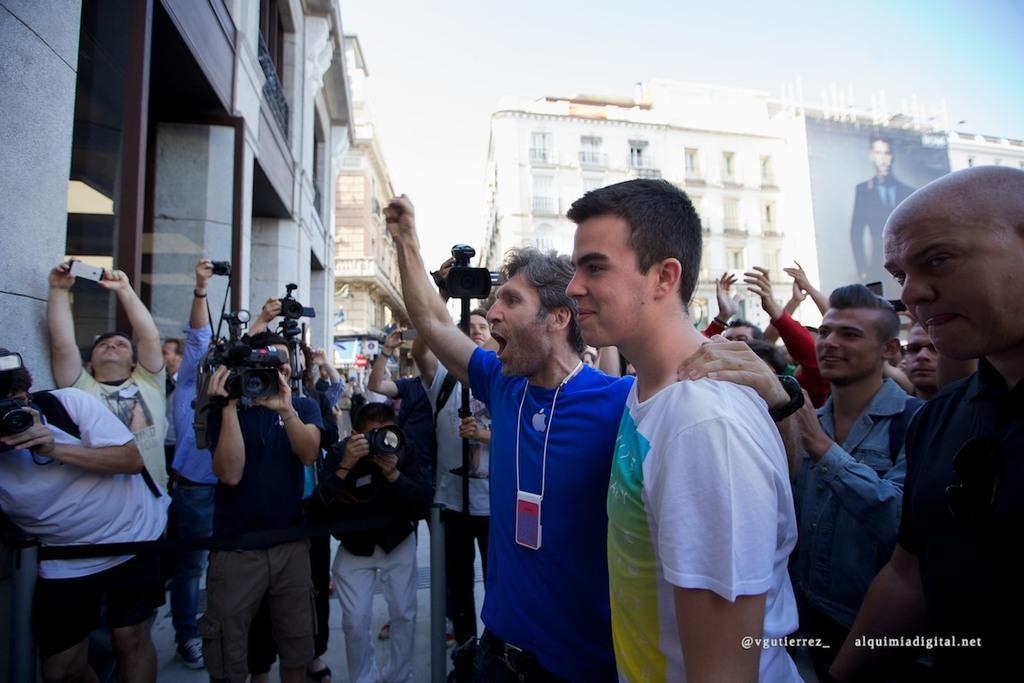In one or two sentences, can you explain what this image depicts? In this image there are many people in front of the building. Some of them are holding camera. In the background there are buildings. There is a banner over here. 